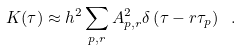<formula> <loc_0><loc_0><loc_500><loc_500>K ( \tau ) \approx h ^ { 2 } \sum _ { p , r } A _ { p , r } ^ { 2 } \delta \left ( \tau - r \tau _ { p } \right ) \ .</formula> 